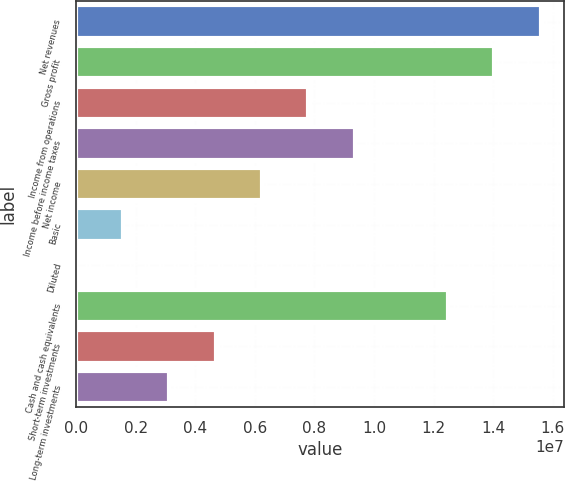Convert chart. <chart><loc_0><loc_0><loc_500><loc_500><bar_chart><fcel>Net revenues<fcel>Gross profit<fcel>Income from operations<fcel>Income before income taxes<fcel>Net income<fcel>Basic<fcel>Diluted<fcel>Cash and cash equivalents<fcel>Short-term investments<fcel>Long-term investments<nl><fcel>1.55924e+07<fcel>1.40332e+07<fcel>7.79622e+06<fcel>9.35546e+06<fcel>6.23698e+06<fcel>1.55925e+06<fcel>1.36<fcel>1.2474e+07<fcel>4.67773e+06<fcel>3.11849e+06<nl></chart> 